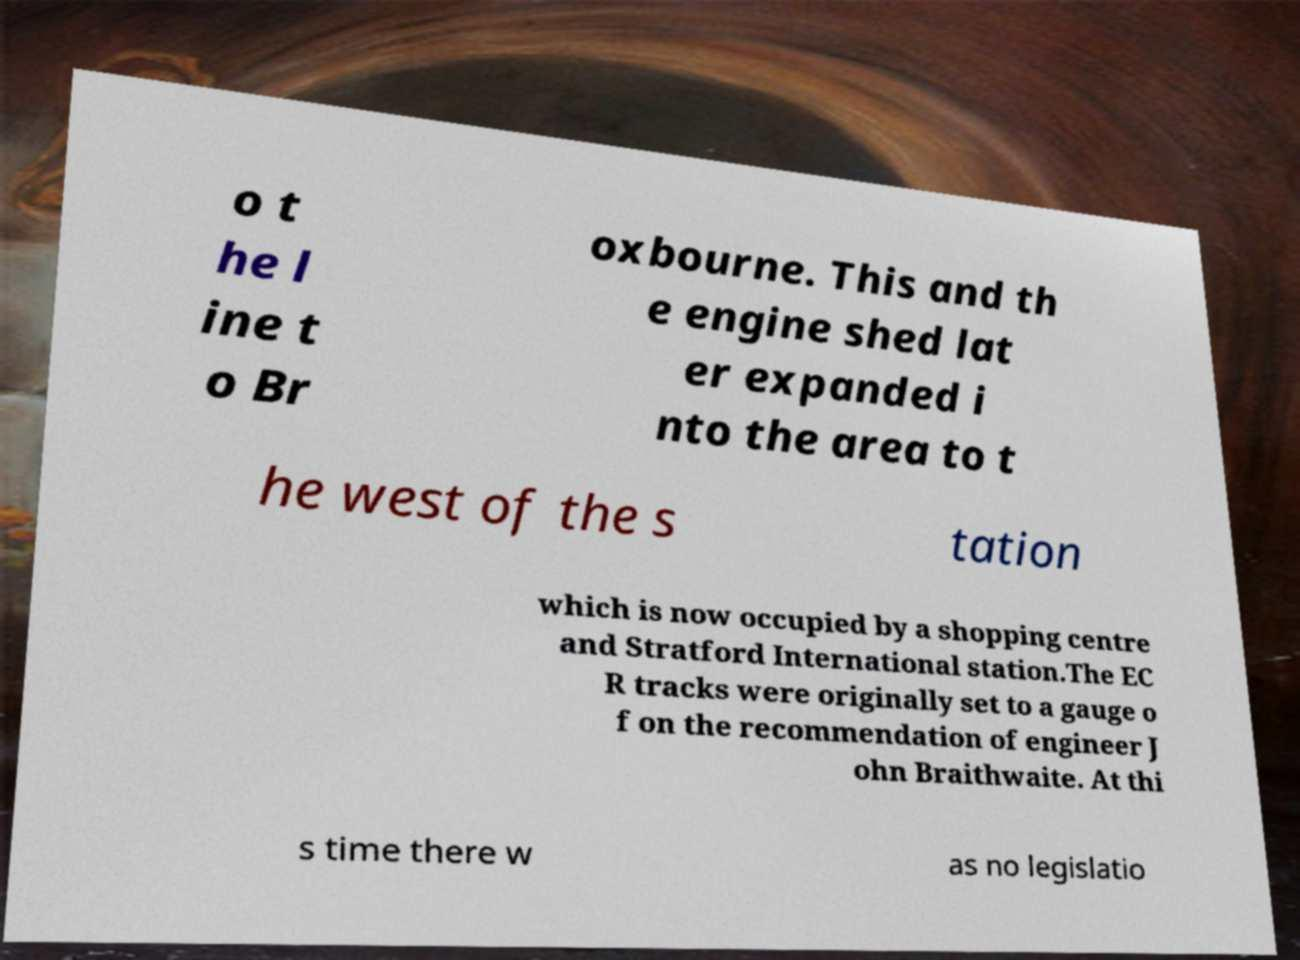Can you read and provide the text displayed in the image?This photo seems to have some interesting text. Can you extract and type it out for me? o t he l ine t o Br oxbourne. This and th e engine shed lat er expanded i nto the area to t he west of the s tation which is now occupied by a shopping centre and Stratford International station.The EC R tracks were originally set to a gauge o f on the recommendation of engineer J ohn Braithwaite. At thi s time there w as no legislatio 